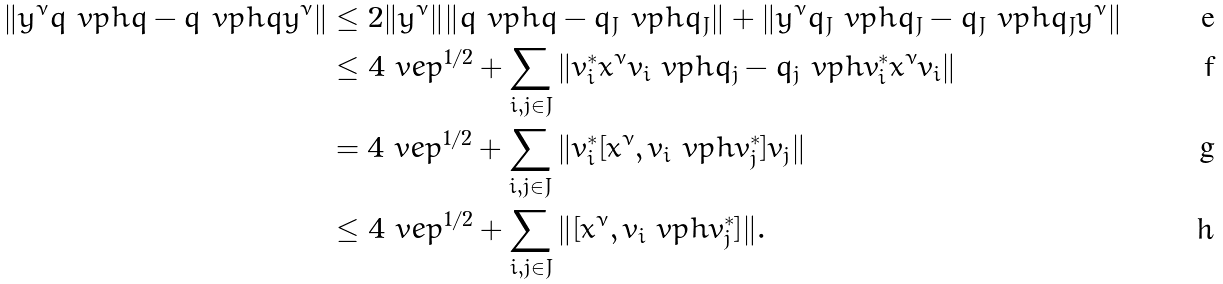<formula> <loc_0><loc_0><loc_500><loc_500>\| y ^ { \nu } q \ v p h q - q \ v p h q y ^ { \nu } \| & \leq 2 \| y ^ { \nu } \| \| q \ v p h q - q _ { J } \ v p h q _ { J } \| + \| y ^ { \nu } q _ { J } \ v p h q _ { J } - q _ { J } \ v p h q _ { J } y ^ { \nu } \| \\ & \leq 4 \ v e p ^ { 1 / 2 } + \sum _ { i , j \in J } \| v _ { i } ^ { * } x ^ { \nu } v _ { i } \ v p h q _ { j } - q _ { j } \ v p h v _ { i } ^ { * } x ^ { \nu } v _ { i } \| \\ & = 4 \ v e p ^ { 1 / 2 } + \sum _ { i , j \in J } \| v _ { i } ^ { * } [ x ^ { \nu } , v _ { i } \ v p h v _ { j } ^ { * } ] v _ { j } \| \\ & \leq 4 \ v e p ^ { 1 / 2 } + \sum _ { i , j \in J } \| [ x ^ { \nu } , v _ { i } \ v p h v _ { j } ^ { * } ] \| .</formula> 